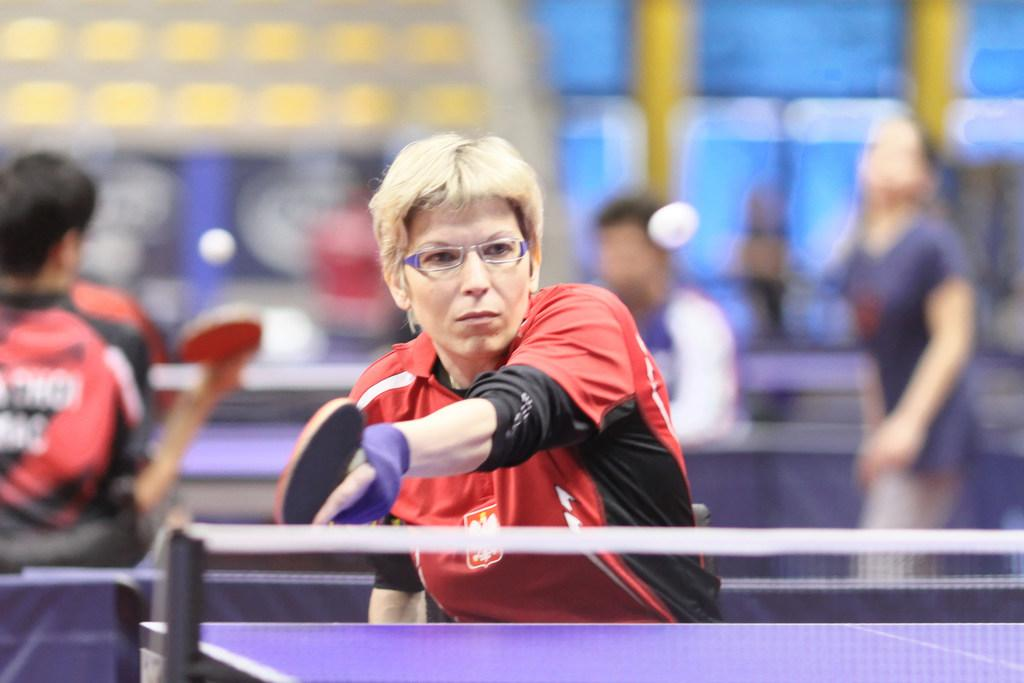What activity are the people in the image engaged in? The people in the image are playing table tennis. Can you describe the background of the image? The background of the image is blurry. What type of story is being told at the airport in the image? There is no airport or story present in the image; it features people playing table tennis. What tool is being used to fix the wrench in the image? There is no wrench or tool present in the image. 